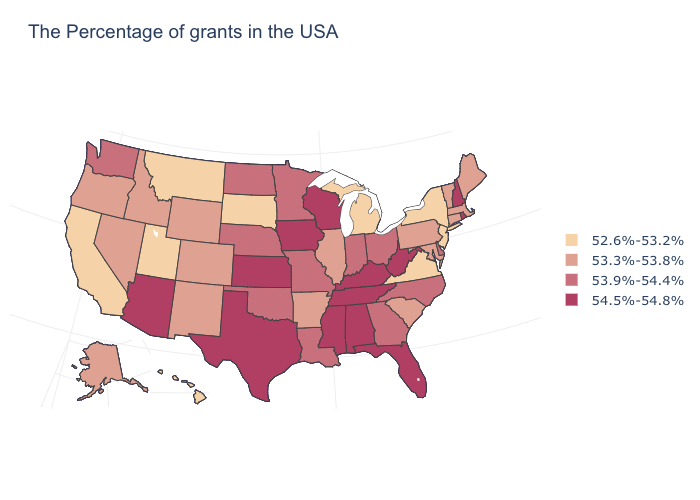What is the value of Utah?
Keep it brief. 52.6%-53.2%. Which states have the highest value in the USA?
Be succinct. Rhode Island, New Hampshire, West Virginia, Florida, Kentucky, Alabama, Tennessee, Wisconsin, Mississippi, Iowa, Kansas, Texas, Arizona. What is the value of South Dakota?
Keep it brief. 52.6%-53.2%. Which states hav the highest value in the South?
Concise answer only. West Virginia, Florida, Kentucky, Alabama, Tennessee, Mississippi, Texas. Name the states that have a value in the range 52.6%-53.2%?
Concise answer only. New York, New Jersey, Virginia, Michigan, South Dakota, Utah, Montana, California, Hawaii. Name the states that have a value in the range 54.5%-54.8%?
Write a very short answer. Rhode Island, New Hampshire, West Virginia, Florida, Kentucky, Alabama, Tennessee, Wisconsin, Mississippi, Iowa, Kansas, Texas, Arizona. What is the value of Wyoming?
Concise answer only. 53.3%-53.8%. What is the lowest value in the MidWest?
Concise answer only. 52.6%-53.2%. Which states have the lowest value in the West?
Concise answer only. Utah, Montana, California, Hawaii. Name the states that have a value in the range 53.9%-54.4%?
Be succinct. Delaware, North Carolina, Ohio, Georgia, Indiana, Louisiana, Missouri, Minnesota, Nebraska, Oklahoma, North Dakota, Washington. Name the states that have a value in the range 53.3%-53.8%?
Be succinct. Maine, Massachusetts, Vermont, Connecticut, Maryland, Pennsylvania, South Carolina, Illinois, Arkansas, Wyoming, Colorado, New Mexico, Idaho, Nevada, Oregon, Alaska. Does the map have missing data?
Be succinct. No. What is the value of Hawaii?
Answer briefly. 52.6%-53.2%. Name the states that have a value in the range 53.9%-54.4%?
Concise answer only. Delaware, North Carolina, Ohio, Georgia, Indiana, Louisiana, Missouri, Minnesota, Nebraska, Oklahoma, North Dakota, Washington. Is the legend a continuous bar?
Answer briefly. No. 